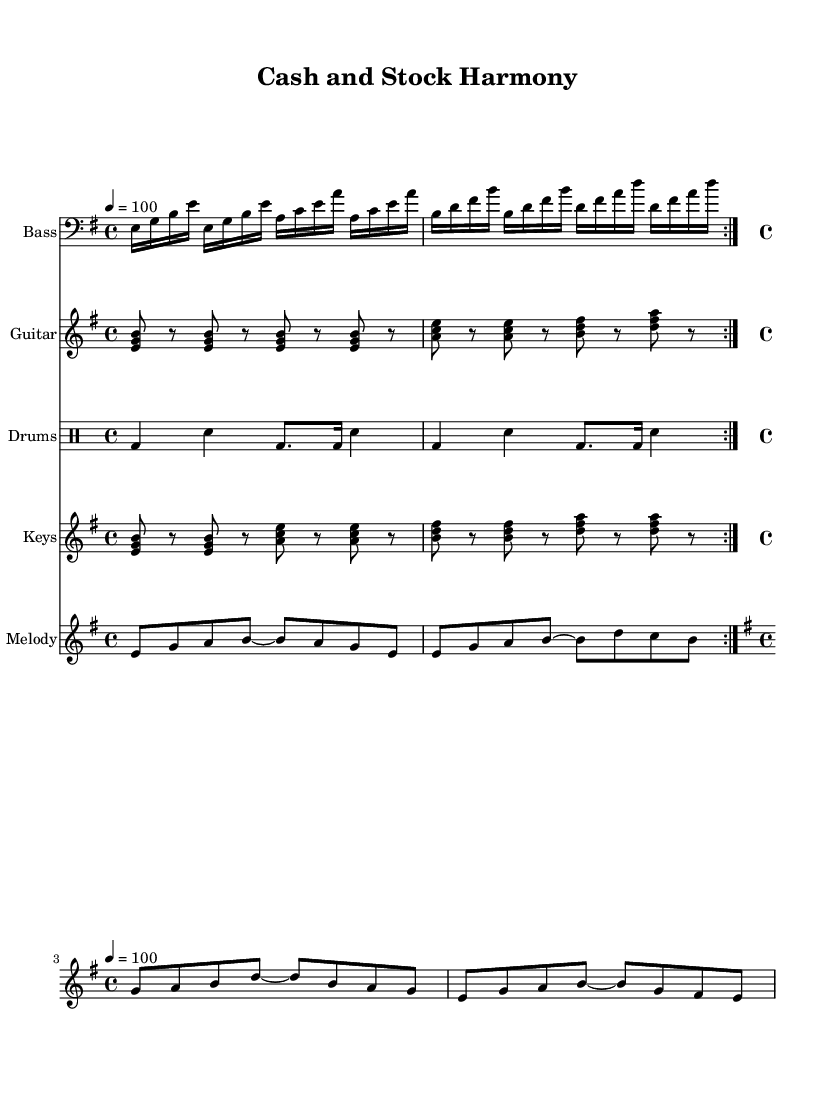What is the key signature of this music? The key signature is indicated by the number of sharps or flats shown at the beginning of the staff. In this case, there are no sharps or flats, indicating it is in E minor, which has one sharp, F#.
Answer: E minor What is the time signature of this piece? The time signature is displayed at the beginning of the music, indicating how many beats are in each measure. Here, the time signature is 4/4, meaning there are four beats per measure.
Answer: 4/4 What is the tempo marking for this piece? The tempo marking is given at the start of the music in beats per minute. In this score, the marking indicates a tempo of 100 beats per minute.
Answer: 100 How many measures are in the bass line section? By counting the measures in the bass line, we can see it is repeated twice, and each section consists of four measures, totaling eight measures in the bass line.
Answer: 8 What is the primary instrument group represented in this score? The score includes various instruments, but the primary groups to note are the Bass, Guitar, Drums, Keys, and Melody. Each has its own staff showing the arrangement. The focus can be on rhythm and harmony typical of Funk music.
Answer: Bass, Guitar, Drums, Keys, Melody Which instrument plays the riff that complements the bass line? The riff that complements the bass line comes from the guitar part indicated in the score, which is designed to sync with the groove established by the bass.
Answer: Guitar What is the function of the drum part in this piece? The drum part is mainly responsible for maintaining the rhythm and energy characteristic of Funk music. The beats indicated in the drummode help to drive the groove throughout the piece.
Answer: Maintain rhythm 